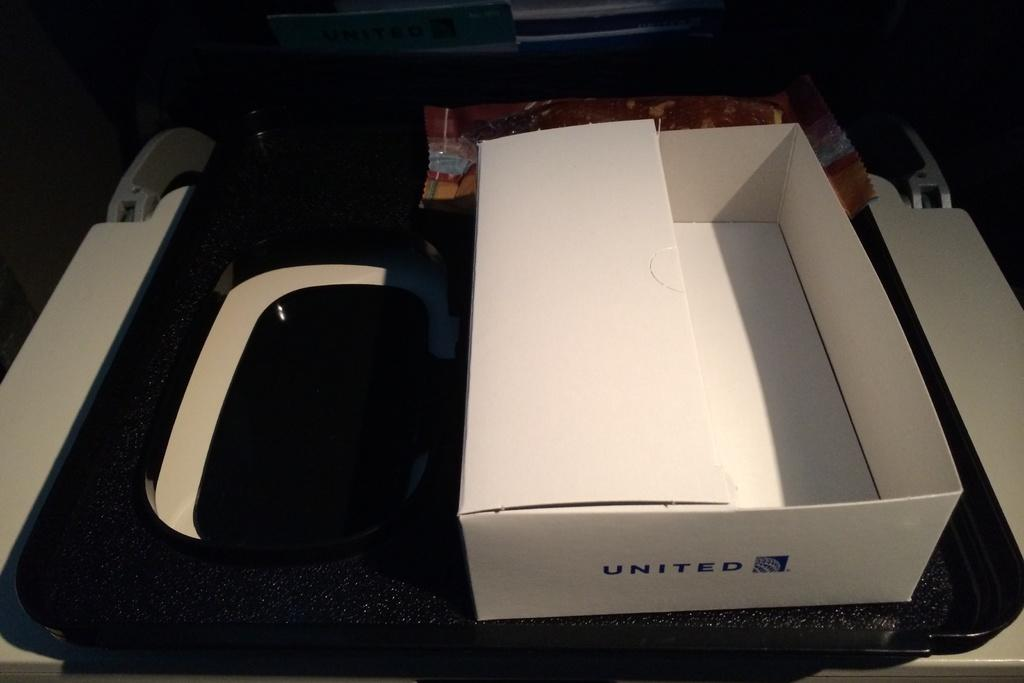<image>
Share a concise interpretation of the image provided. An empty with box with United written on it. 